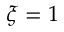Convert formula to latex. <formula><loc_0><loc_0><loc_500><loc_500>\xi = 1</formula> 